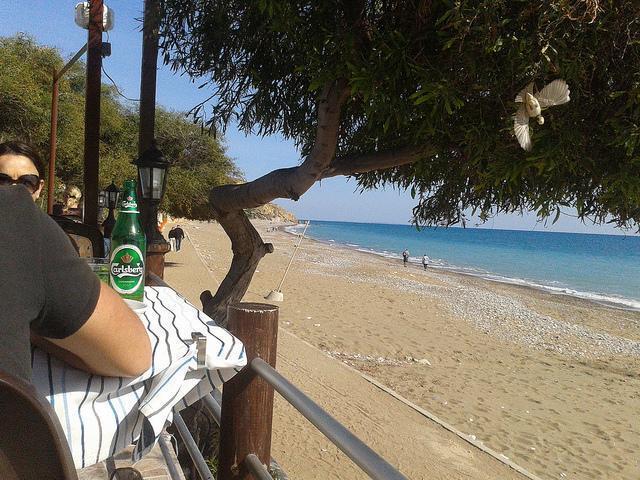What is inside the green bottle on the table?
Choose the right answer from the provided options to respond to the question.
Options: Juice, beer, champagne, wine. Beer. 